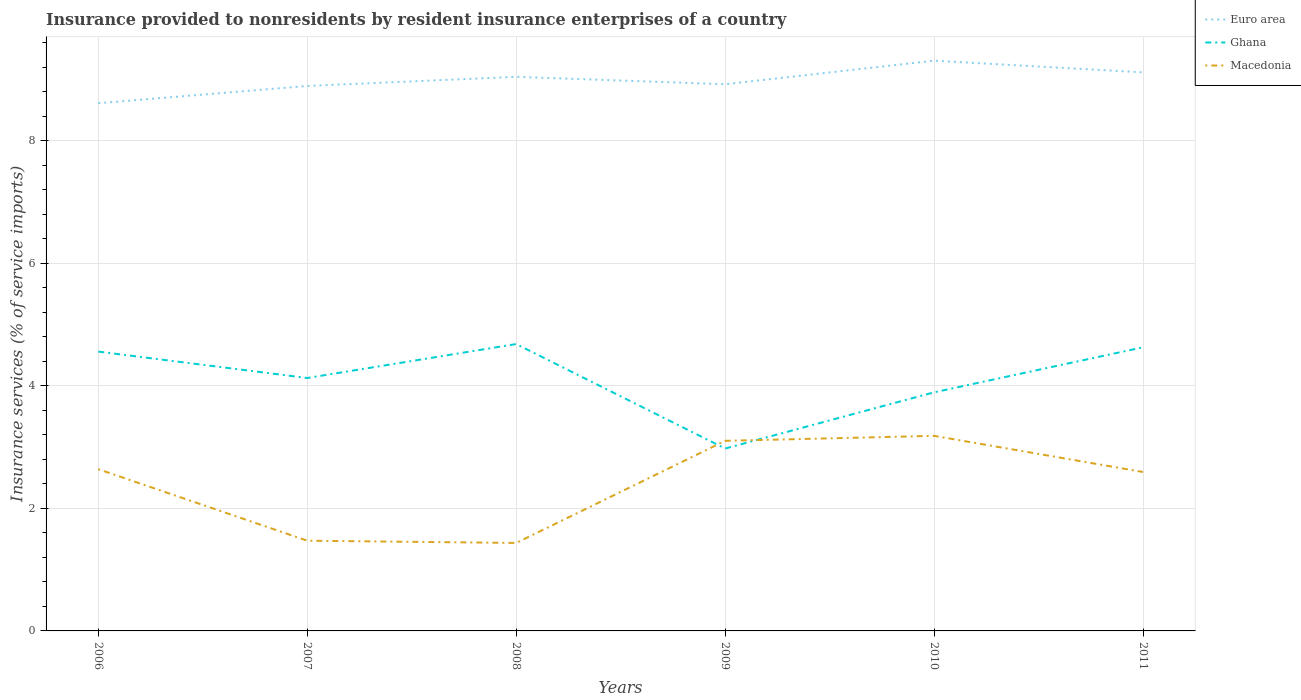Across all years, what is the maximum insurance provided to nonresidents in Ghana?
Provide a short and direct response. 2.98. In which year was the insurance provided to nonresidents in Ghana maximum?
Your answer should be compact. 2009. What is the total insurance provided to nonresidents in Ghana in the graph?
Your answer should be very brief. -0.07. What is the difference between the highest and the second highest insurance provided to nonresidents in Euro area?
Provide a short and direct response. 0.69. How many lines are there?
Your response must be concise. 3. What is the difference between two consecutive major ticks on the Y-axis?
Provide a short and direct response. 2. Does the graph contain any zero values?
Keep it short and to the point. No. How many legend labels are there?
Offer a very short reply. 3. What is the title of the graph?
Your answer should be compact. Insurance provided to nonresidents by resident insurance enterprises of a country. Does "Latin America(all income levels)" appear as one of the legend labels in the graph?
Keep it short and to the point. No. What is the label or title of the X-axis?
Provide a succinct answer. Years. What is the label or title of the Y-axis?
Make the answer very short. Insurance services (% of service imports). What is the Insurance services (% of service imports) of Euro area in 2006?
Ensure brevity in your answer.  8.61. What is the Insurance services (% of service imports) of Ghana in 2006?
Keep it short and to the point. 4.56. What is the Insurance services (% of service imports) of Macedonia in 2006?
Provide a short and direct response. 2.64. What is the Insurance services (% of service imports) in Euro area in 2007?
Your answer should be very brief. 8.9. What is the Insurance services (% of service imports) of Ghana in 2007?
Give a very brief answer. 4.13. What is the Insurance services (% of service imports) in Macedonia in 2007?
Provide a short and direct response. 1.47. What is the Insurance services (% of service imports) in Euro area in 2008?
Give a very brief answer. 9.04. What is the Insurance services (% of service imports) in Ghana in 2008?
Provide a short and direct response. 4.68. What is the Insurance services (% of service imports) in Macedonia in 2008?
Your answer should be very brief. 1.44. What is the Insurance services (% of service imports) of Euro area in 2009?
Make the answer very short. 8.92. What is the Insurance services (% of service imports) of Ghana in 2009?
Give a very brief answer. 2.98. What is the Insurance services (% of service imports) of Macedonia in 2009?
Your response must be concise. 3.1. What is the Insurance services (% of service imports) in Euro area in 2010?
Your answer should be compact. 9.31. What is the Insurance services (% of service imports) of Ghana in 2010?
Make the answer very short. 3.89. What is the Insurance services (% of service imports) of Macedonia in 2010?
Your response must be concise. 3.18. What is the Insurance services (% of service imports) in Euro area in 2011?
Provide a short and direct response. 9.12. What is the Insurance services (% of service imports) in Ghana in 2011?
Keep it short and to the point. 4.63. What is the Insurance services (% of service imports) of Macedonia in 2011?
Make the answer very short. 2.59. Across all years, what is the maximum Insurance services (% of service imports) of Euro area?
Your answer should be compact. 9.31. Across all years, what is the maximum Insurance services (% of service imports) of Ghana?
Provide a short and direct response. 4.68. Across all years, what is the maximum Insurance services (% of service imports) of Macedonia?
Provide a short and direct response. 3.18. Across all years, what is the minimum Insurance services (% of service imports) of Euro area?
Give a very brief answer. 8.61. Across all years, what is the minimum Insurance services (% of service imports) in Ghana?
Offer a terse response. 2.98. Across all years, what is the minimum Insurance services (% of service imports) of Macedonia?
Your answer should be very brief. 1.44. What is the total Insurance services (% of service imports) of Euro area in the graph?
Provide a short and direct response. 53.9. What is the total Insurance services (% of service imports) in Ghana in the graph?
Keep it short and to the point. 24.87. What is the total Insurance services (% of service imports) of Macedonia in the graph?
Provide a succinct answer. 14.43. What is the difference between the Insurance services (% of service imports) of Euro area in 2006 and that in 2007?
Provide a succinct answer. -0.28. What is the difference between the Insurance services (% of service imports) in Ghana in 2006 and that in 2007?
Your answer should be compact. 0.43. What is the difference between the Insurance services (% of service imports) in Macedonia in 2006 and that in 2007?
Your response must be concise. 1.17. What is the difference between the Insurance services (% of service imports) of Euro area in 2006 and that in 2008?
Your response must be concise. -0.43. What is the difference between the Insurance services (% of service imports) of Ghana in 2006 and that in 2008?
Provide a succinct answer. -0.12. What is the difference between the Insurance services (% of service imports) in Macedonia in 2006 and that in 2008?
Provide a short and direct response. 1.2. What is the difference between the Insurance services (% of service imports) of Euro area in 2006 and that in 2009?
Your answer should be compact. -0.31. What is the difference between the Insurance services (% of service imports) in Ghana in 2006 and that in 2009?
Make the answer very short. 1.58. What is the difference between the Insurance services (% of service imports) in Macedonia in 2006 and that in 2009?
Offer a very short reply. -0.46. What is the difference between the Insurance services (% of service imports) in Euro area in 2006 and that in 2010?
Give a very brief answer. -0.69. What is the difference between the Insurance services (% of service imports) in Ghana in 2006 and that in 2010?
Your answer should be compact. 0.66. What is the difference between the Insurance services (% of service imports) of Macedonia in 2006 and that in 2010?
Ensure brevity in your answer.  -0.54. What is the difference between the Insurance services (% of service imports) in Euro area in 2006 and that in 2011?
Ensure brevity in your answer.  -0.5. What is the difference between the Insurance services (% of service imports) in Ghana in 2006 and that in 2011?
Your answer should be very brief. -0.07. What is the difference between the Insurance services (% of service imports) in Macedonia in 2006 and that in 2011?
Make the answer very short. 0.05. What is the difference between the Insurance services (% of service imports) of Euro area in 2007 and that in 2008?
Give a very brief answer. -0.15. What is the difference between the Insurance services (% of service imports) of Ghana in 2007 and that in 2008?
Make the answer very short. -0.55. What is the difference between the Insurance services (% of service imports) of Macedonia in 2007 and that in 2008?
Offer a very short reply. 0.04. What is the difference between the Insurance services (% of service imports) in Euro area in 2007 and that in 2009?
Make the answer very short. -0.03. What is the difference between the Insurance services (% of service imports) of Ghana in 2007 and that in 2009?
Give a very brief answer. 1.15. What is the difference between the Insurance services (% of service imports) of Macedonia in 2007 and that in 2009?
Your answer should be very brief. -1.63. What is the difference between the Insurance services (% of service imports) of Euro area in 2007 and that in 2010?
Ensure brevity in your answer.  -0.41. What is the difference between the Insurance services (% of service imports) of Ghana in 2007 and that in 2010?
Provide a short and direct response. 0.23. What is the difference between the Insurance services (% of service imports) of Macedonia in 2007 and that in 2010?
Ensure brevity in your answer.  -1.71. What is the difference between the Insurance services (% of service imports) of Euro area in 2007 and that in 2011?
Ensure brevity in your answer.  -0.22. What is the difference between the Insurance services (% of service imports) of Ghana in 2007 and that in 2011?
Provide a succinct answer. -0.5. What is the difference between the Insurance services (% of service imports) of Macedonia in 2007 and that in 2011?
Keep it short and to the point. -1.12. What is the difference between the Insurance services (% of service imports) of Euro area in 2008 and that in 2009?
Give a very brief answer. 0.12. What is the difference between the Insurance services (% of service imports) in Ghana in 2008 and that in 2009?
Provide a short and direct response. 1.71. What is the difference between the Insurance services (% of service imports) in Macedonia in 2008 and that in 2009?
Make the answer very short. -1.67. What is the difference between the Insurance services (% of service imports) in Euro area in 2008 and that in 2010?
Keep it short and to the point. -0.26. What is the difference between the Insurance services (% of service imports) of Ghana in 2008 and that in 2010?
Offer a terse response. 0.79. What is the difference between the Insurance services (% of service imports) of Macedonia in 2008 and that in 2010?
Your response must be concise. -1.75. What is the difference between the Insurance services (% of service imports) in Euro area in 2008 and that in 2011?
Make the answer very short. -0.07. What is the difference between the Insurance services (% of service imports) in Ghana in 2008 and that in 2011?
Your response must be concise. 0.05. What is the difference between the Insurance services (% of service imports) in Macedonia in 2008 and that in 2011?
Provide a succinct answer. -1.16. What is the difference between the Insurance services (% of service imports) of Euro area in 2009 and that in 2010?
Offer a very short reply. -0.38. What is the difference between the Insurance services (% of service imports) of Ghana in 2009 and that in 2010?
Give a very brief answer. -0.92. What is the difference between the Insurance services (% of service imports) of Macedonia in 2009 and that in 2010?
Make the answer very short. -0.08. What is the difference between the Insurance services (% of service imports) in Euro area in 2009 and that in 2011?
Your answer should be very brief. -0.19. What is the difference between the Insurance services (% of service imports) of Ghana in 2009 and that in 2011?
Your response must be concise. -1.65. What is the difference between the Insurance services (% of service imports) of Macedonia in 2009 and that in 2011?
Give a very brief answer. 0.51. What is the difference between the Insurance services (% of service imports) in Euro area in 2010 and that in 2011?
Ensure brevity in your answer.  0.19. What is the difference between the Insurance services (% of service imports) of Ghana in 2010 and that in 2011?
Your response must be concise. -0.74. What is the difference between the Insurance services (% of service imports) in Macedonia in 2010 and that in 2011?
Make the answer very short. 0.59. What is the difference between the Insurance services (% of service imports) of Euro area in 2006 and the Insurance services (% of service imports) of Ghana in 2007?
Give a very brief answer. 4.49. What is the difference between the Insurance services (% of service imports) of Euro area in 2006 and the Insurance services (% of service imports) of Macedonia in 2007?
Your answer should be compact. 7.14. What is the difference between the Insurance services (% of service imports) in Ghana in 2006 and the Insurance services (% of service imports) in Macedonia in 2007?
Your answer should be very brief. 3.09. What is the difference between the Insurance services (% of service imports) in Euro area in 2006 and the Insurance services (% of service imports) in Ghana in 2008?
Give a very brief answer. 3.93. What is the difference between the Insurance services (% of service imports) in Euro area in 2006 and the Insurance services (% of service imports) in Macedonia in 2008?
Give a very brief answer. 7.18. What is the difference between the Insurance services (% of service imports) of Ghana in 2006 and the Insurance services (% of service imports) of Macedonia in 2008?
Offer a terse response. 3.12. What is the difference between the Insurance services (% of service imports) of Euro area in 2006 and the Insurance services (% of service imports) of Ghana in 2009?
Give a very brief answer. 5.64. What is the difference between the Insurance services (% of service imports) of Euro area in 2006 and the Insurance services (% of service imports) of Macedonia in 2009?
Provide a short and direct response. 5.51. What is the difference between the Insurance services (% of service imports) of Ghana in 2006 and the Insurance services (% of service imports) of Macedonia in 2009?
Provide a short and direct response. 1.46. What is the difference between the Insurance services (% of service imports) of Euro area in 2006 and the Insurance services (% of service imports) of Ghana in 2010?
Your answer should be very brief. 4.72. What is the difference between the Insurance services (% of service imports) in Euro area in 2006 and the Insurance services (% of service imports) in Macedonia in 2010?
Your answer should be very brief. 5.43. What is the difference between the Insurance services (% of service imports) of Ghana in 2006 and the Insurance services (% of service imports) of Macedonia in 2010?
Provide a short and direct response. 1.38. What is the difference between the Insurance services (% of service imports) of Euro area in 2006 and the Insurance services (% of service imports) of Ghana in 2011?
Provide a short and direct response. 3.98. What is the difference between the Insurance services (% of service imports) in Euro area in 2006 and the Insurance services (% of service imports) in Macedonia in 2011?
Your answer should be compact. 6.02. What is the difference between the Insurance services (% of service imports) in Ghana in 2006 and the Insurance services (% of service imports) in Macedonia in 2011?
Offer a terse response. 1.97. What is the difference between the Insurance services (% of service imports) in Euro area in 2007 and the Insurance services (% of service imports) in Ghana in 2008?
Your answer should be compact. 4.21. What is the difference between the Insurance services (% of service imports) in Euro area in 2007 and the Insurance services (% of service imports) in Macedonia in 2008?
Your response must be concise. 7.46. What is the difference between the Insurance services (% of service imports) of Ghana in 2007 and the Insurance services (% of service imports) of Macedonia in 2008?
Provide a succinct answer. 2.69. What is the difference between the Insurance services (% of service imports) of Euro area in 2007 and the Insurance services (% of service imports) of Ghana in 2009?
Provide a succinct answer. 5.92. What is the difference between the Insurance services (% of service imports) of Euro area in 2007 and the Insurance services (% of service imports) of Macedonia in 2009?
Provide a short and direct response. 5.79. What is the difference between the Insurance services (% of service imports) in Ghana in 2007 and the Insurance services (% of service imports) in Macedonia in 2009?
Provide a short and direct response. 1.03. What is the difference between the Insurance services (% of service imports) in Euro area in 2007 and the Insurance services (% of service imports) in Ghana in 2010?
Ensure brevity in your answer.  5. What is the difference between the Insurance services (% of service imports) of Euro area in 2007 and the Insurance services (% of service imports) of Macedonia in 2010?
Keep it short and to the point. 5.71. What is the difference between the Insurance services (% of service imports) of Ghana in 2007 and the Insurance services (% of service imports) of Macedonia in 2010?
Provide a short and direct response. 0.94. What is the difference between the Insurance services (% of service imports) of Euro area in 2007 and the Insurance services (% of service imports) of Ghana in 2011?
Provide a succinct answer. 4.27. What is the difference between the Insurance services (% of service imports) of Euro area in 2007 and the Insurance services (% of service imports) of Macedonia in 2011?
Provide a succinct answer. 6.3. What is the difference between the Insurance services (% of service imports) of Ghana in 2007 and the Insurance services (% of service imports) of Macedonia in 2011?
Keep it short and to the point. 1.53. What is the difference between the Insurance services (% of service imports) of Euro area in 2008 and the Insurance services (% of service imports) of Ghana in 2009?
Your answer should be very brief. 6.07. What is the difference between the Insurance services (% of service imports) of Euro area in 2008 and the Insurance services (% of service imports) of Macedonia in 2009?
Your answer should be very brief. 5.94. What is the difference between the Insurance services (% of service imports) of Ghana in 2008 and the Insurance services (% of service imports) of Macedonia in 2009?
Your answer should be very brief. 1.58. What is the difference between the Insurance services (% of service imports) in Euro area in 2008 and the Insurance services (% of service imports) in Ghana in 2010?
Provide a short and direct response. 5.15. What is the difference between the Insurance services (% of service imports) of Euro area in 2008 and the Insurance services (% of service imports) of Macedonia in 2010?
Your response must be concise. 5.86. What is the difference between the Insurance services (% of service imports) of Ghana in 2008 and the Insurance services (% of service imports) of Macedonia in 2010?
Make the answer very short. 1.5. What is the difference between the Insurance services (% of service imports) in Euro area in 2008 and the Insurance services (% of service imports) in Ghana in 2011?
Offer a very short reply. 4.41. What is the difference between the Insurance services (% of service imports) in Euro area in 2008 and the Insurance services (% of service imports) in Macedonia in 2011?
Offer a terse response. 6.45. What is the difference between the Insurance services (% of service imports) in Ghana in 2008 and the Insurance services (% of service imports) in Macedonia in 2011?
Ensure brevity in your answer.  2.09. What is the difference between the Insurance services (% of service imports) in Euro area in 2009 and the Insurance services (% of service imports) in Ghana in 2010?
Give a very brief answer. 5.03. What is the difference between the Insurance services (% of service imports) in Euro area in 2009 and the Insurance services (% of service imports) in Macedonia in 2010?
Your response must be concise. 5.74. What is the difference between the Insurance services (% of service imports) of Ghana in 2009 and the Insurance services (% of service imports) of Macedonia in 2010?
Keep it short and to the point. -0.21. What is the difference between the Insurance services (% of service imports) of Euro area in 2009 and the Insurance services (% of service imports) of Ghana in 2011?
Offer a very short reply. 4.29. What is the difference between the Insurance services (% of service imports) of Euro area in 2009 and the Insurance services (% of service imports) of Macedonia in 2011?
Offer a terse response. 6.33. What is the difference between the Insurance services (% of service imports) of Ghana in 2009 and the Insurance services (% of service imports) of Macedonia in 2011?
Offer a terse response. 0.38. What is the difference between the Insurance services (% of service imports) in Euro area in 2010 and the Insurance services (% of service imports) in Ghana in 2011?
Make the answer very short. 4.68. What is the difference between the Insurance services (% of service imports) of Euro area in 2010 and the Insurance services (% of service imports) of Macedonia in 2011?
Provide a succinct answer. 6.71. What is the difference between the Insurance services (% of service imports) of Ghana in 2010 and the Insurance services (% of service imports) of Macedonia in 2011?
Your answer should be very brief. 1.3. What is the average Insurance services (% of service imports) of Euro area per year?
Your answer should be very brief. 8.98. What is the average Insurance services (% of service imports) of Ghana per year?
Your answer should be very brief. 4.15. What is the average Insurance services (% of service imports) in Macedonia per year?
Your response must be concise. 2.4. In the year 2006, what is the difference between the Insurance services (% of service imports) of Euro area and Insurance services (% of service imports) of Ghana?
Provide a succinct answer. 4.05. In the year 2006, what is the difference between the Insurance services (% of service imports) of Euro area and Insurance services (% of service imports) of Macedonia?
Your response must be concise. 5.97. In the year 2006, what is the difference between the Insurance services (% of service imports) of Ghana and Insurance services (% of service imports) of Macedonia?
Make the answer very short. 1.92. In the year 2007, what is the difference between the Insurance services (% of service imports) of Euro area and Insurance services (% of service imports) of Ghana?
Provide a succinct answer. 4.77. In the year 2007, what is the difference between the Insurance services (% of service imports) in Euro area and Insurance services (% of service imports) in Macedonia?
Keep it short and to the point. 7.42. In the year 2007, what is the difference between the Insurance services (% of service imports) of Ghana and Insurance services (% of service imports) of Macedonia?
Ensure brevity in your answer.  2.66. In the year 2008, what is the difference between the Insurance services (% of service imports) of Euro area and Insurance services (% of service imports) of Ghana?
Your answer should be compact. 4.36. In the year 2008, what is the difference between the Insurance services (% of service imports) of Euro area and Insurance services (% of service imports) of Macedonia?
Offer a very short reply. 7.61. In the year 2008, what is the difference between the Insurance services (% of service imports) of Ghana and Insurance services (% of service imports) of Macedonia?
Your answer should be compact. 3.25. In the year 2009, what is the difference between the Insurance services (% of service imports) in Euro area and Insurance services (% of service imports) in Ghana?
Give a very brief answer. 5.95. In the year 2009, what is the difference between the Insurance services (% of service imports) in Euro area and Insurance services (% of service imports) in Macedonia?
Your response must be concise. 5.82. In the year 2009, what is the difference between the Insurance services (% of service imports) of Ghana and Insurance services (% of service imports) of Macedonia?
Your answer should be very brief. -0.13. In the year 2010, what is the difference between the Insurance services (% of service imports) in Euro area and Insurance services (% of service imports) in Ghana?
Give a very brief answer. 5.41. In the year 2010, what is the difference between the Insurance services (% of service imports) of Euro area and Insurance services (% of service imports) of Macedonia?
Your answer should be compact. 6.12. In the year 2010, what is the difference between the Insurance services (% of service imports) in Ghana and Insurance services (% of service imports) in Macedonia?
Your answer should be compact. 0.71. In the year 2011, what is the difference between the Insurance services (% of service imports) in Euro area and Insurance services (% of service imports) in Ghana?
Give a very brief answer. 4.49. In the year 2011, what is the difference between the Insurance services (% of service imports) of Euro area and Insurance services (% of service imports) of Macedonia?
Offer a very short reply. 6.52. In the year 2011, what is the difference between the Insurance services (% of service imports) in Ghana and Insurance services (% of service imports) in Macedonia?
Keep it short and to the point. 2.04. What is the ratio of the Insurance services (% of service imports) in Euro area in 2006 to that in 2007?
Offer a terse response. 0.97. What is the ratio of the Insurance services (% of service imports) of Ghana in 2006 to that in 2007?
Keep it short and to the point. 1.1. What is the ratio of the Insurance services (% of service imports) in Macedonia in 2006 to that in 2007?
Offer a terse response. 1.79. What is the ratio of the Insurance services (% of service imports) of Euro area in 2006 to that in 2008?
Provide a succinct answer. 0.95. What is the ratio of the Insurance services (% of service imports) of Ghana in 2006 to that in 2008?
Offer a very short reply. 0.97. What is the ratio of the Insurance services (% of service imports) of Macedonia in 2006 to that in 2008?
Make the answer very short. 1.84. What is the ratio of the Insurance services (% of service imports) of Euro area in 2006 to that in 2009?
Offer a very short reply. 0.97. What is the ratio of the Insurance services (% of service imports) of Ghana in 2006 to that in 2009?
Provide a succinct answer. 1.53. What is the ratio of the Insurance services (% of service imports) in Macedonia in 2006 to that in 2009?
Give a very brief answer. 0.85. What is the ratio of the Insurance services (% of service imports) of Euro area in 2006 to that in 2010?
Keep it short and to the point. 0.93. What is the ratio of the Insurance services (% of service imports) in Ghana in 2006 to that in 2010?
Keep it short and to the point. 1.17. What is the ratio of the Insurance services (% of service imports) in Macedonia in 2006 to that in 2010?
Your response must be concise. 0.83. What is the ratio of the Insurance services (% of service imports) in Euro area in 2006 to that in 2011?
Keep it short and to the point. 0.94. What is the ratio of the Insurance services (% of service imports) in Macedonia in 2006 to that in 2011?
Offer a very short reply. 1.02. What is the ratio of the Insurance services (% of service imports) in Euro area in 2007 to that in 2008?
Offer a very short reply. 0.98. What is the ratio of the Insurance services (% of service imports) of Ghana in 2007 to that in 2008?
Provide a short and direct response. 0.88. What is the ratio of the Insurance services (% of service imports) of Macedonia in 2007 to that in 2008?
Your answer should be compact. 1.03. What is the ratio of the Insurance services (% of service imports) in Ghana in 2007 to that in 2009?
Ensure brevity in your answer.  1.39. What is the ratio of the Insurance services (% of service imports) in Macedonia in 2007 to that in 2009?
Your response must be concise. 0.47. What is the ratio of the Insurance services (% of service imports) in Euro area in 2007 to that in 2010?
Keep it short and to the point. 0.96. What is the ratio of the Insurance services (% of service imports) in Ghana in 2007 to that in 2010?
Offer a terse response. 1.06. What is the ratio of the Insurance services (% of service imports) in Macedonia in 2007 to that in 2010?
Provide a short and direct response. 0.46. What is the ratio of the Insurance services (% of service imports) in Euro area in 2007 to that in 2011?
Provide a short and direct response. 0.98. What is the ratio of the Insurance services (% of service imports) of Ghana in 2007 to that in 2011?
Make the answer very short. 0.89. What is the ratio of the Insurance services (% of service imports) of Macedonia in 2007 to that in 2011?
Your answer should be compact. 0.57. What is the ratio of the Insurance services (% of service imports) of Euro area in 2008 to that in 2009?
Offer a very short reply. 1.01. What is the ratio of the Insurance services (% of service imports) in Ghana in 2008 to that in 2009?
Keep it short and to the point. 1.57. What is the ratio of the Insurance services (% of service imports) in Macedonia in 2008 to that in 2009?
Your response must be concise. 0.46. What is the ratio of the Insurance services (% of service imports) in Euro area in 2008 to that in 2010?
Your response must be concise. 0.97. What is the ratio of the Insurance services (% of service imports) in Ghana in 2008 to that in 2010?
Keep it short and to the point. 1.2. What is the ratio of the Insurance services (% of service imports) in Macedonia in 2008 to that in 2010?
Keep it short and to the point. 0.45. What is the ratio of the Insurance services (% of service imports) in Euro area in 2008 to that in 2011?
Provide a succinct answer. 0.99. What is the ratio of the Insurance services (% of service imports) in Ghana in 2008 to that in 2011?
Ensure brevity in your answer.  1.01. What is the ratio of the Insurance services (% of service imports) in Macedonia in 2008 to that in 2011?
Your answer should be compact. 0.55. What is the ratio of the Insurance services (% of service imports) in Euro area in 2009 to that in 2010?
Provide a short and direct response. 0.96. What is the ratio of the Insurance services (% of service imports) in Ghana in 2009 to that in 2010?
Your response must be concise. 0.76. What is the ratio of the Insurance services (% of service imports) in Macedonia in 2009 to that in 2010?
Provide a short and direct response. 0.97. What is the ratio of the Insurance services (% of service imports) of Euro area in 2009 to that in 2011?
Your answer should be very brief. 0.98. What is the ratio of the Insurance services (% of service imports) in Ghana in 2009 to that in 2011?
Provide a short and direct response. 0.64. What is the ratio of the Insurance services (% of service imports) of Macedonia in 2009 to that in 2011?
Offer a very short reply. 1.2. What is the ratio of the Insurance services (% of service imports) of Euro area in 2010 to that in 2011?
Ensure brevity in your answer.  1.02. What is the ratio of the Insurance services (% of service imports) in Ghana in 2010 to that in 2011?
Your response must be concise. 0.84. What is the ratio of the Insurance services (% of service imports) in Macedonia in 2010 to that in 2011?
Offer a very short reply. 1.23. What is the difference between the highest and the second highest Insurance services (% of service imports) of Euro area?
Ensure brevity in your answer.  0.19. What is the difference between the highest and the second highest Insurance services (% of service imports) of Ghana?
Provide a succinct answer. 0.05. What is the difference between the highest and the second highest Insurance services (% of service imports) in Macedonia?
Ensure brevity in your answer.  0.08. What is the difference between the highest and the lowest Insurance services (% of service imports) of Euro area?
Provide a succinct answer. 0.69. What is the difference between the highest and the lowest Insurance services (% of service imports) in Ghana?
Provide a succinct answer. 1.71. What is the difference between the highest and the lowest Insurance services (% of service imports) in Macedonia?
Give a very brief answer. 1.75. 